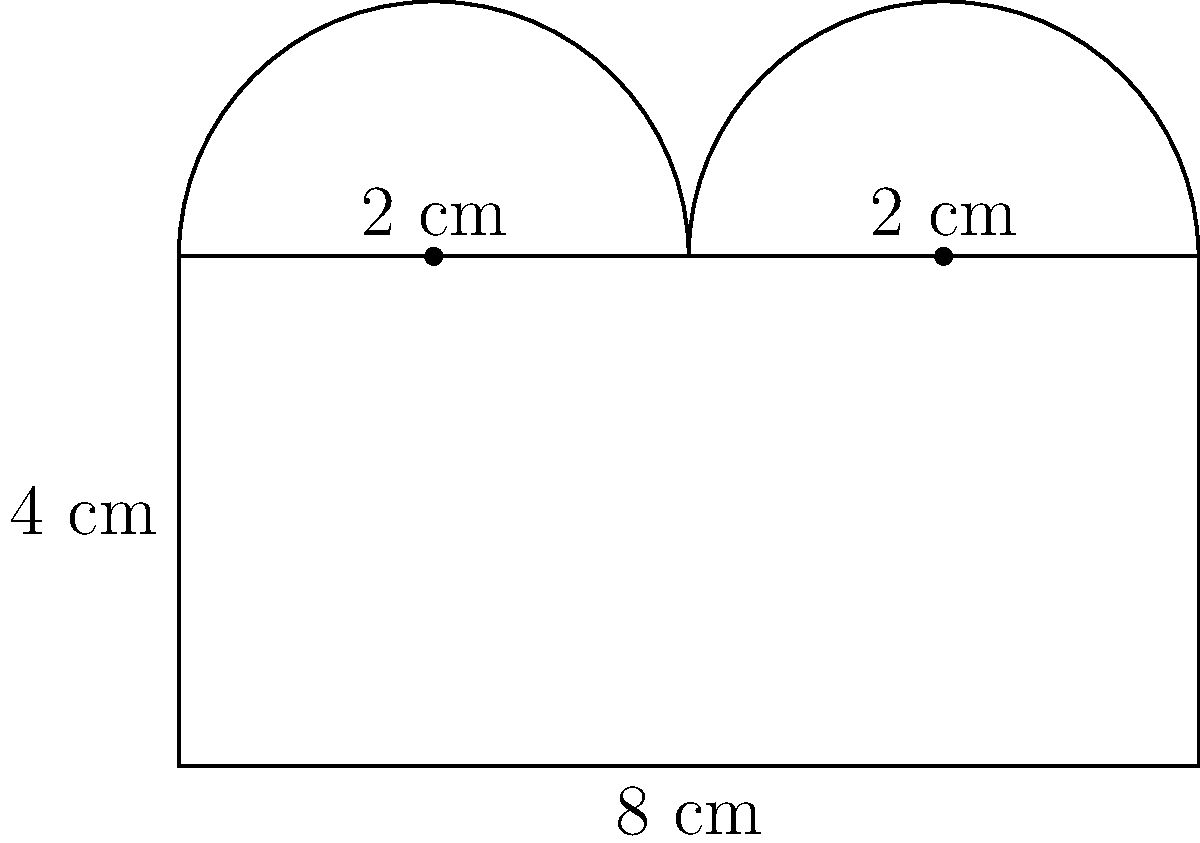Calculate the total area of the composite shape shown above. The shape consists of a rectangle with two semicircles on top. All measurements are in centimeters. To find the total area, we need to calculate the areas of the rectangle and the two semicircles separately, then add them together.

1. Area of the rectangle:
   $A_{rectangle} = length \times width = 8 \times 4 = 32$ cm²

2. Area of each semicircle:
   $A_{semicircle} = \frac{1}{2} \times \pi r^2$
   where $r$ is the radius (2 cm)
   $A_{semicircle} = \frac{1}{2} \times \pi \times 2^2 = 2\pi$ cm²

3. Total area of both semicircles:
   $A_{total semicircles} = 2 \times 2\pi = 4\pi$ cm²

4. Total area of the composite shape:
   $A_{total} = A_{rectangle} + A_{total semicircles}$
   $A_{total} = 32 + 4\pi$ cm²

Therefore, the total area is $32 + 4\pi$ cm².
Answer: $32 + 4\pi$ cm² 